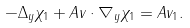<formula> <loc_0><loc_0><loc_500><loc_500>- \Delta _ { y } \chi _ { 1 } + A v \cdot \nabla _ { y } \chi _ { 1 } = A v _ { 1 } .</formula> 